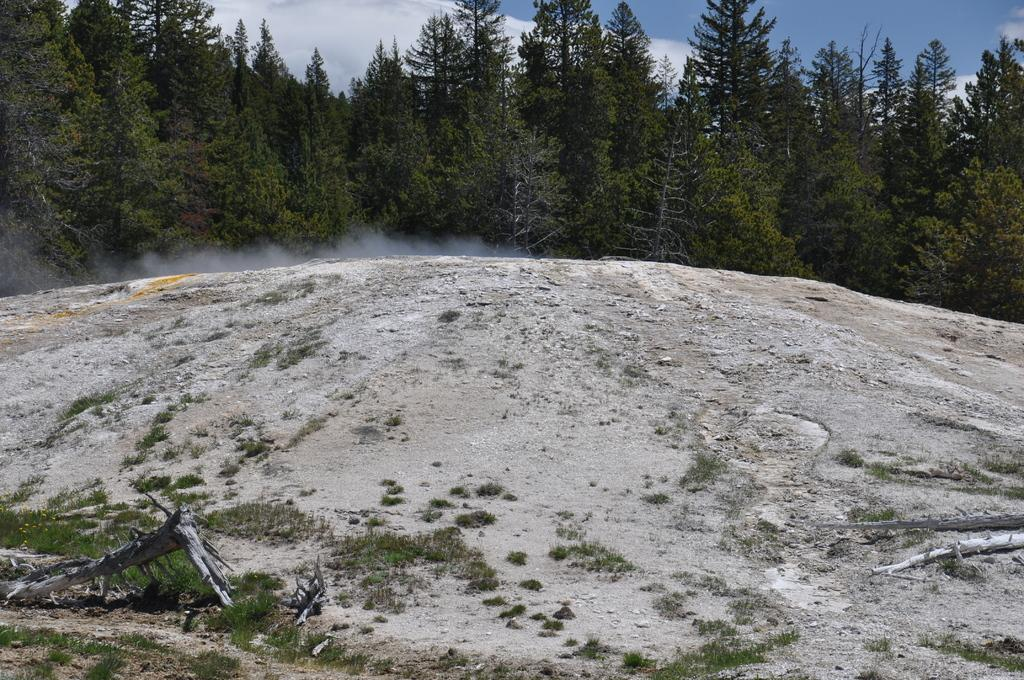What is the main feature of the image's center? The center of the image contains the sky. What can be observed in the sky? Clouds are visible in the sky. What type of vegetation is present in the image? Trees and grass are present in the image. Can you describe the tree in the image? There is a single stem of a tree in the image. Is there any indication of human activity in the image? Yes, smoke is visible in the image, which might suggest human activity. Can you tell me the name of the aunt who signed the receipt in the image? There is no receipt or aunt present in the image. What type of order is being processed in the image? There is no order being processed in the image. 